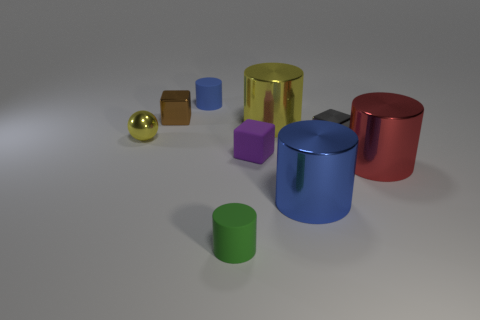Subtract 1 cylinders. How many cylinders are left? 4 Subtract all red cylinders. How many cylinders are left? 4 Subtract all tiny green cylinders. How many cylinders are left? 4 Subtract all gray cylinders. Subtract all brown spheres. How many cylinders are left? 5 Add 1 yellow metallic objects. How many objects exist? 10 Subtract all blocks. How many objects are left? 6 Subtract all matte cubes. Subtract all tiny blue objects. How many objects are left? 7 Add 5 tiny blue matte objects. How many tiny blue matte objects are left? 6 Add 3 big red things. How many big red things exist? 4 Subtract 0 blue balls. How many objects are left? 9 